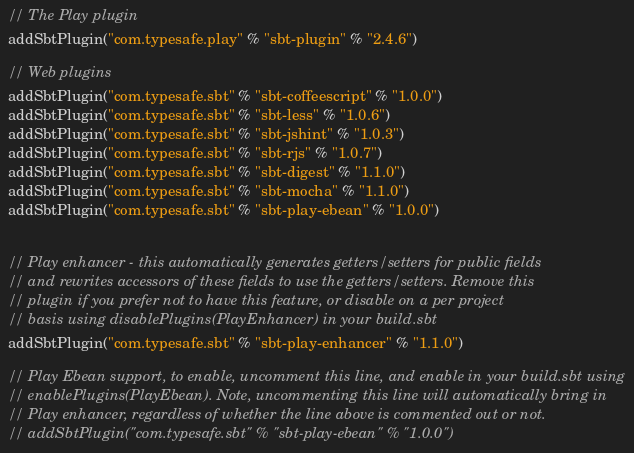<code> <loc_0><loc_0><loc_500><loc_500><_Scala_>// The Play plugin
addSbtPlugin("com.typesafe.play" % "sbt-plugin" % "2.4.6")

// Web plugins
addSbtPlugin("com.typesafe.sbt" % "sbt-coffeescript" % "1.0.0")
addSbtPlugin("com.typesafe.sbt" % "sbt-less" % "1.0.6")
addSbtPlugin("com.typesafe.sbt" % "sbt-jshint" % "1.0.3")
addSbtPlugin("com.typesafe.sbt" % "sbt-rjs" % "1.0.7")
addSbtPlugin("com.typesafe.sbt" % "sbt-digest" % "1.1.0")
addSbtPlugin("com.typesafe.sbt" % "sbt-mocha" % "1.1.0")
addSbtPlugin("com.typesafe.sbt" % "sbt-play-ebean" % "1.0.0")


// Play enhancer - this automatically generates getters/setters for public fields
// and rewrites accessors of these fields to use the getters/setters. Remove this
// plugin if you prefer not to have this feature, or disable on a per project
// basis using disablePlugins(PlayEnhancer) in your build.sbt
addSbtPlugin("com.typesafe.sbt" % "sbt-play-enhancer" % "1.1.0")

// Play Ebean support, to enable, uncomment this line, and enable in your build.sbt using
// enablePlugins(PlayEbean). Note, uncommenting this line will automatically bring in
// Play enhancer, regardless of whether the line above is commented out or not.
// addSbtPlugin("com.typesafe.sbt" % "sbt-play-ebean" % "1.0.0")
</code> 